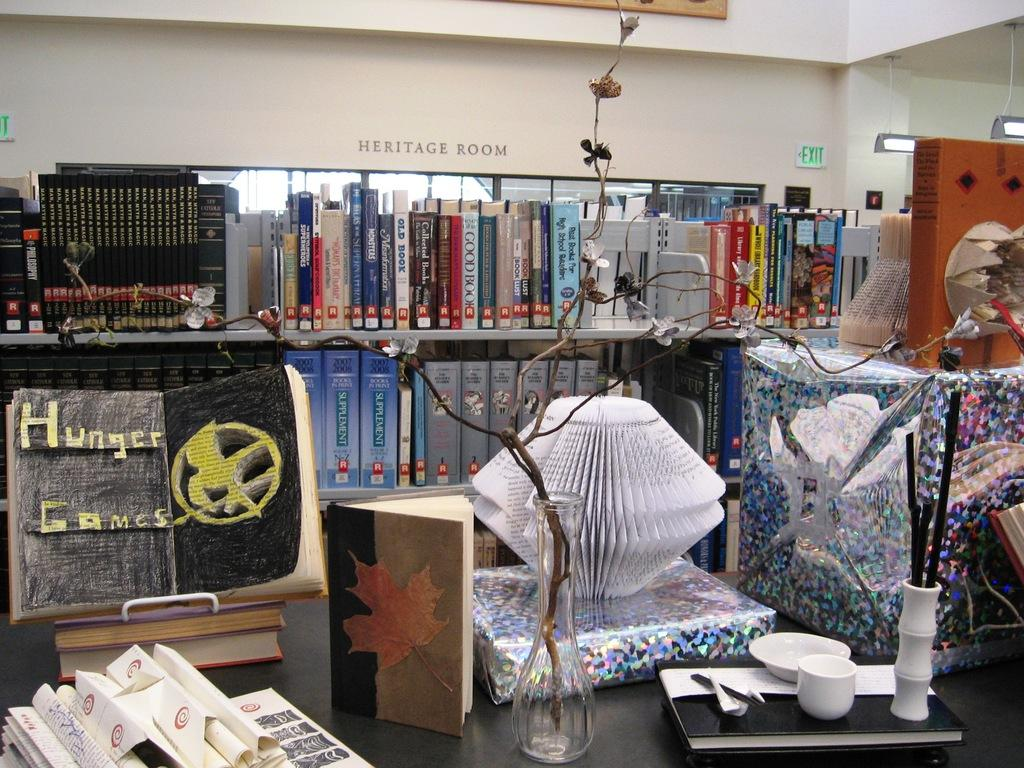<image>
Present a compact description of the photo's key features. The window inside a cluttered store has the words HERITAGE ROOM right above it. 